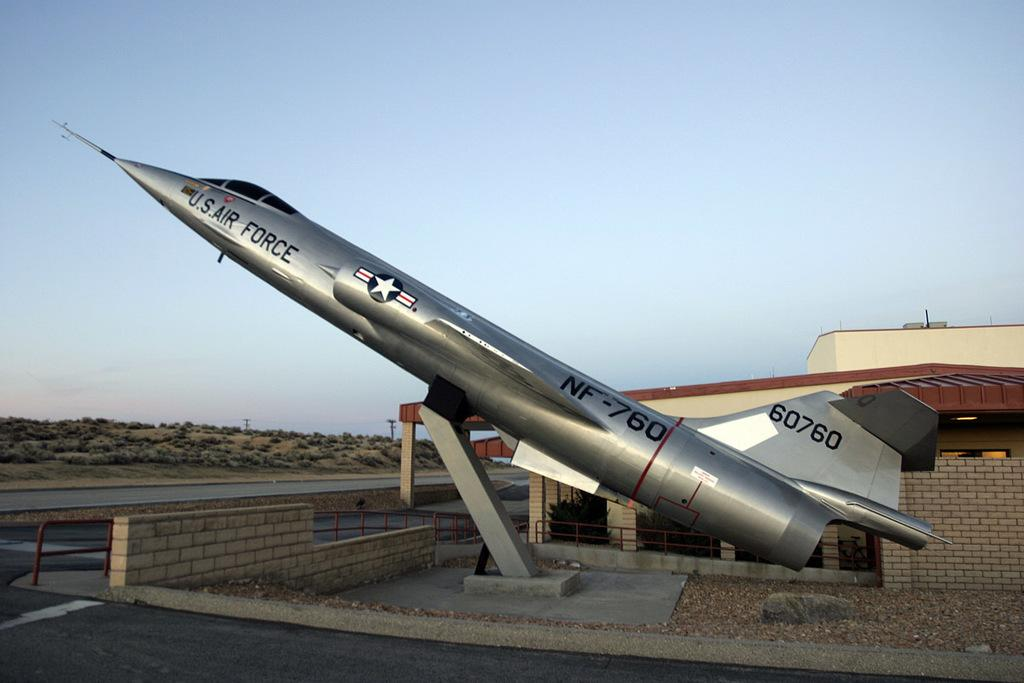What is the main subject of the picture? The main subject of the picture is an aeroplane. What other structures or objects can be seen in the picture? There is a building, a wall, a fence, and poles on the left side of the picture. What is visible in the background of the picture? The sky is visible in the picture. What type of skin can be seen on the aeroplane in the image? There is no skin visible on the aeroplane in the image, as it is a machine and not a living organism. How does the grip of the aeroplane change throughout the image? The grip of the aeroplane does not change throughout the image, as it is a static object in the picture. 